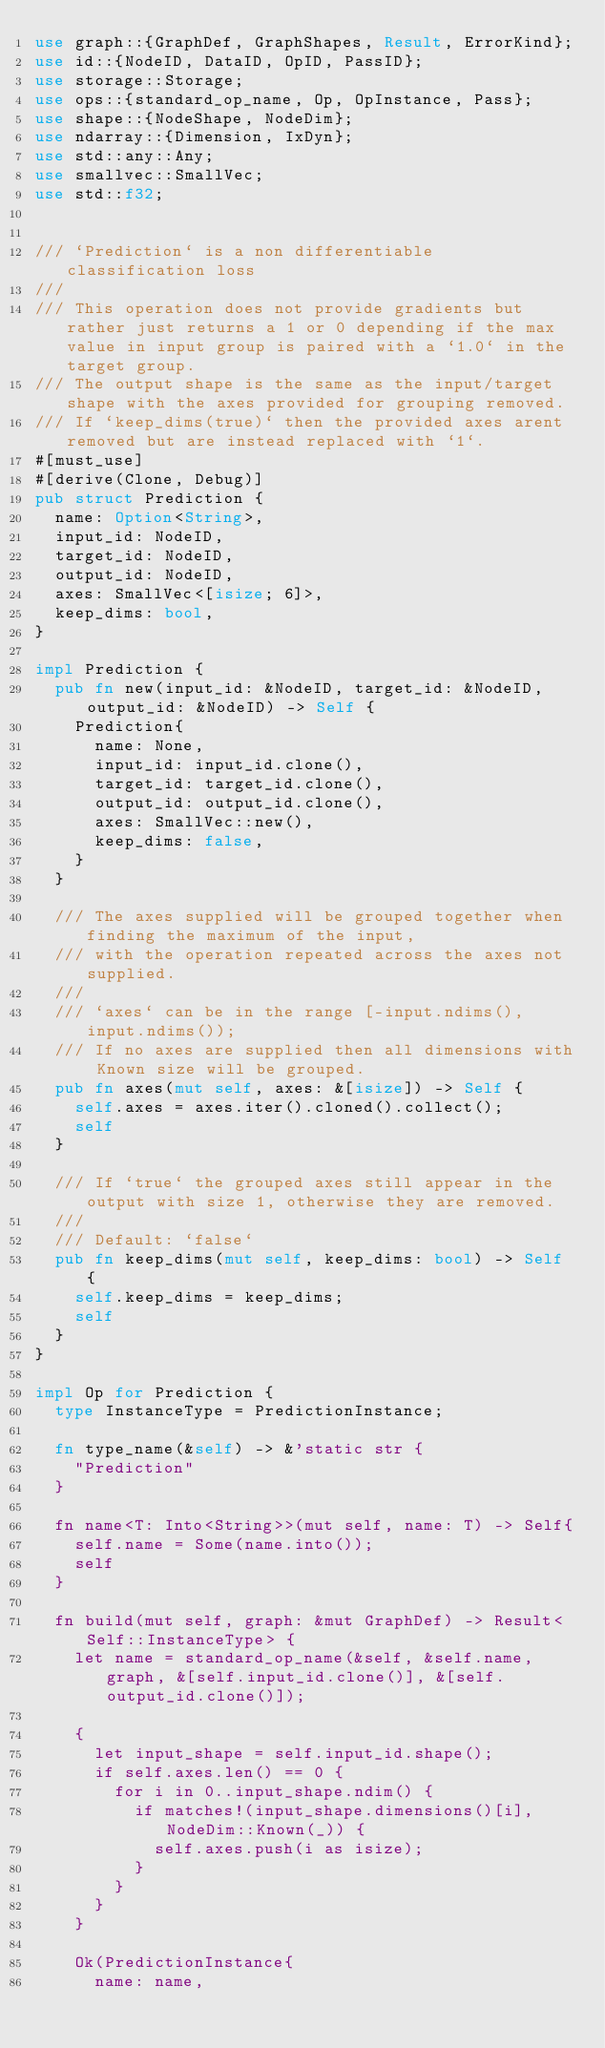Convert code to text. <code><loc_0><loc_0><loc_500><loc_500><_Rust_>use graph::{GraphDef, GraphShapes, Result, ErrorKind};
use id::{NodeID, DataID, OpID, PassID};
use storage::Storage;
use ops::{standard_op_name, Op, OpInstance, Pass};
use shape::{NodeShape, NodeDim};
use ndarray::{Dimension, IxDyn};
use std::any::Any;
use smallvec::SmallVec;
use std::f32;


/// `Prediction` is a non differentiable classification loss
///
/// This operation does not provide gradients but rather just returns a 1 or 0 depending if the max value in input group is paired with a `1.0` in the target group.
/// The output shape is the same as the input/target shape with the axes provided for grouping removed.
/// If `keep_dims(true)` then the provided axes arent removed but are instead replaced with `1`.
#[must_use]
#[derive(Clone, Debug)]
pub struct Prediction {
	name: Option<String>,
	input_id: NodeID,
	target_id: NodeID,
	output_id: NodeID,
	axes: SmallVec<[isize; 6]>,
	keep_dims: bool,
}

impl Prediction {
	pub fn new(input_id: &NodeID, target_id: &NodeID, output_id: &NodeID) -> Self {
		Prediction{
			name: None,
			input_id: input_id.clone(),
			target_id: target_id.clone(),
			output_id: output_id.clone(),
			axes: SmallVec::new(),
			keep_dims: false,
		}
	}

	/// The axes supplied will be grouped together when finding the maximum of the input,
	/// with the operation repeated across the axes not supplied.
	///
	/// `axes` can be in the range [-input.ndims(), input.ndims());
	/// If no axes are supplied then all dimensions with Known size will be grouped.
	pub fn axes(mut self, axes: &[isize]) -> Self {
		self.axes = axes.iter().cloned().collect();
		self
	}

	/// If `true` the grouped axes still appear in the output with size 1, otherwise they are removed.
	///
	/// Default: `false`
	pub fn keep_dims(mut self, keep_dims: bool) -> Self {
		self.keep_dims = keep_dims;
		self
	}
}

impl Op for Prediction {
	type InstanceType = PredictionInstance;

	fn type_name(&self) -> &'static str {
		"Prediction"
	}

	fn name<T: Into<String>>(mut self, name: T) -> Self{
		self.name = Some(name.into());
		self
	}

	fn build(mut self, graph: &mut GraphDef) -> Result<Self::InstanceType> {
		let name = standard_op_name(&self, &self.name, graph, &[self.input_id.clone()], &[self.output_id.clone()]);

		{
			let input_shape = self.input_id.shape();
			if self.axes.len() == 0 {
				for i in 0..input_shape.ndim() {
					if matches!(input_shape.dimensions()[i], NodeDim::Known(_)) {
						self.axes.push(i as isize);
					}
				}
			}
		}

		Ok(PredictionInstance{
			name: name,</code> 